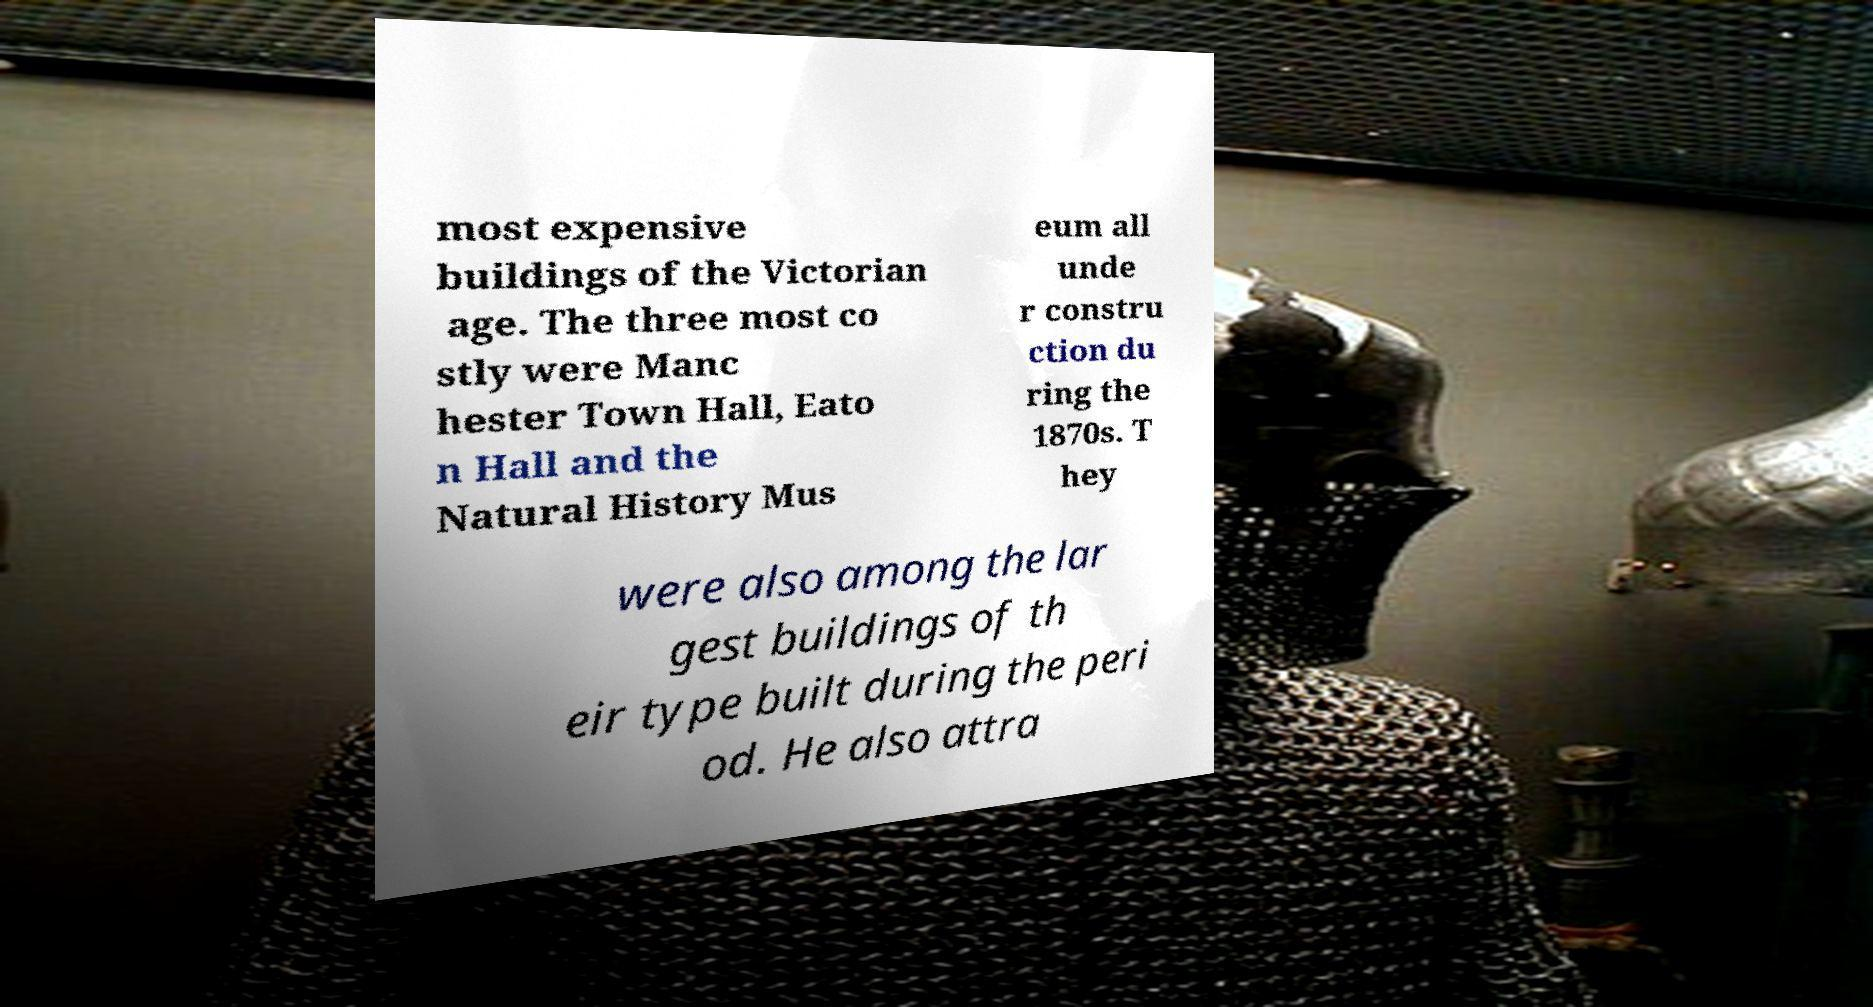Could you assist in decoding the text presented in this image and type it out clearly? most expensive buildings of the Victorian age. The three most co stly were Manc hester Town Hall, Eato n Hall and the Natural History Mus eum all unde r constru ction du ring the 1870s. T hey were also among the lar gest buildings of th eir type built during the peri od. He also attra 